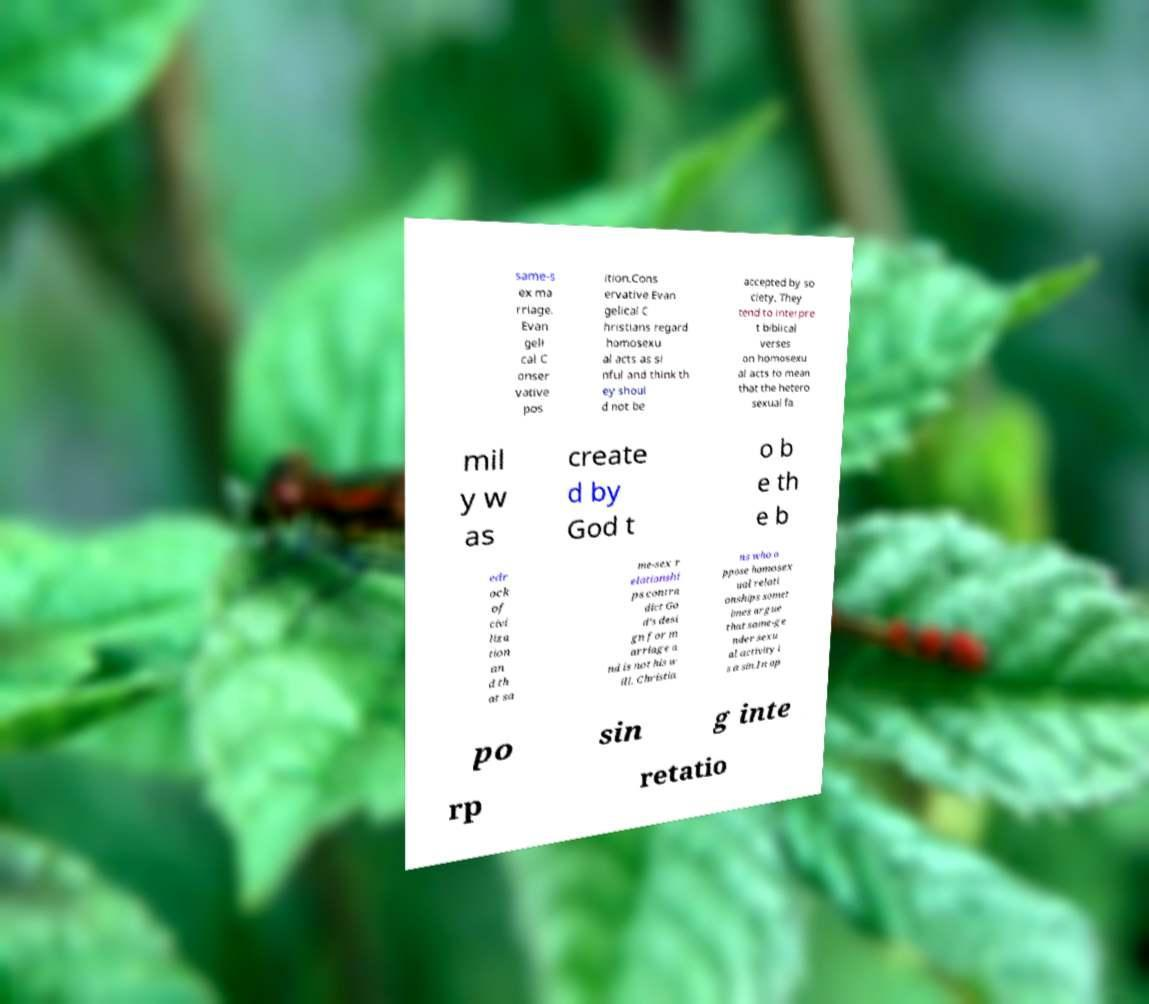Can you read and provide the text displayed in the image?This photo seems to have some interesting text. Can you extract and type it out for me? same-s ex ma rriage. Evan geli cal C onser vative pos ition.Cons ervative Evan gelical C hristians regard homosexu al acts as si nful and think th ey shoul d not be accepted by so ciety. They tend to interpre t biblical verses on homosexu al acts to mean that the hetero sexual fa mil y w as create d by God t o b e th e b edr ock of civi liza tion an d th at sa me-sex r elationshi ps contra dict Go d’s desi gn for m arriage a nd is not his w ill. Christia ns who o ppose homosex ual relati onships somet imes argue that same-ge nder sexu al activity i s a sin.In op po sin g inte rp retatio 